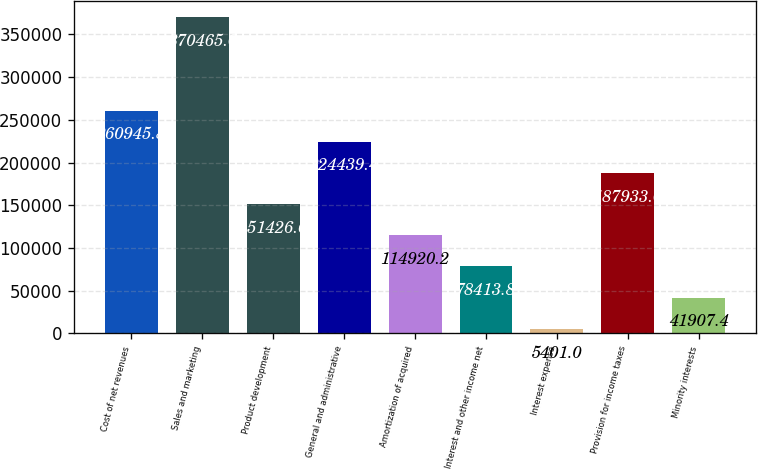<chart> <loc_0><loc_0><loc_500><loc_500><bar_chart><fcel>Cost of net revenues<fcel>Sales and marketing<fcel>Product development<fcel>General and administrative<fcel>Amortization of acquired<fcel>Interest and other income net<fcel>Interest expense<fcel>Provision for income taxes<fcel>Minority interests<nl><fcel>260946<fcel>370465<fcel>151427<fcel>224439<fcel>114920<fcel>78413.8<fcel>5401<fcel>187933<fcel>41907.4<nl></chart> 